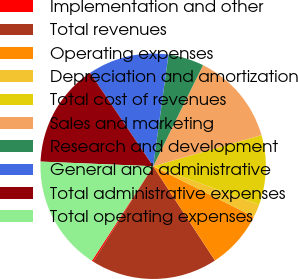<chart> <loc_0><loc_0><loc_500><loc_500><pie_chart><fcel>Implementation and other<fcel>Total revenues<fcel>Operating expenses<fcel>Depreciation and amortization<fcel>Total cost of revenues<fcel>Sales and marketing<fcel>Research and development<fcel>General and administrative<fcel>Total administrative expenses<fcel>Total operating expenses<nl><fcel>0.24%<fcel>18.14%<fcel>8.37%<fcel>1.86%<fcel>10.0%<fcel>13.25%<fcel>5.12%<fcel>11.63%<fcel>14.88%<fcel>16.51%<nl></chart> 